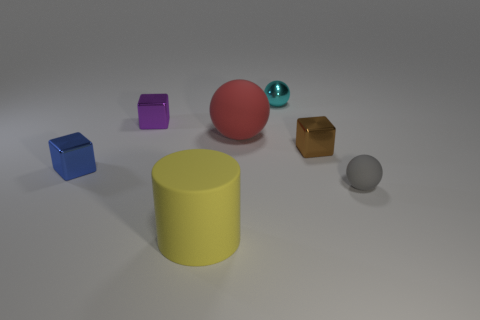Add 1 small green metallic objects. How many objects exist? 8 Subtract all spheres. How many objects are left? 4 Add 5 big green metallic spheres. How many big green metallic spheres exist? 5 Subtract 0 green balls. How many objects are left? 7 Subtract all things. Subtract all big green metallic things. How many objects are left? 0 Add 1 purple metal cubes. How many purple metal cubes are left? 2 